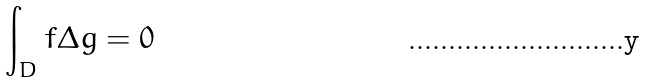Convert formula to latex. <formula><loc_0><loc_0><loc_500><loc_500>\int _ { D } f \Delta g = 0</formula> 